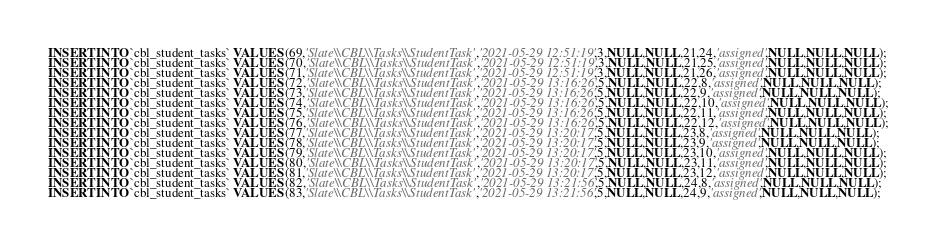<code> <loc_0><loc_0><loc_500><loc_500><_SQL_>INSERT INTO `cbl_student_tasks` VALUES (69,'Slate\\CBL\\Tasks\\StudentTask','2021-05-29 12:51:19',3,NULL,NULL,21,24,'assigned',NULL,NULL,NULL);
INSERT INTO `cbl_student_tasks` VALUES (70,'Slate\\CBL\\Tasks\\StudentTask','2021-05-29 12:51:19',3,NULL,NULL,21,25,'assigned',NULL,NULL,NULL);
INSERT INTO `cbl_student_tasks` VALUES (71,'Slate\\CBL\\Tasks\\StudentTask','2021-05-29 12:51:19',3,NULL,NULL,21,26,'assigned',NULL,NULL,NULL);
INSERT INTO `cbl_student_tasks` VALUES (72,'Slate\\CBL\\Tasks\\StudentTask','2021-05-29 13:16:26',5,NULL,NULL,22,8,'assigned',NULL,NULL,NULL);
INSERT INTO `cbl_student_tasks` VALUES (73,'Slate\\CBL\\Tasks\\StudentTask','2021-05-29 13:16:26',5,NULL,NULL,22,9,'assigned',NULL,NULL,NULL);
INSERT INTO `cbl_student_tasks` VALUES (74,'Slate\\CBL\\Tasks\\StudentTask','2021-05-29 13:16:26',5,NULL,NULL,22,10,'assigned',NULL,NULL,NULL);
INSERT INTO `cbl_student_tasks` VALUES (75,'Slate\\CBL\\Tasks\\StudentTask','2021-05-29 13:16:26',5,NULL,NULL,22,11,'assigned',NULL,NULL,NULL);
INSERT INTO `cbl_student_tasks` VALUES (76,'Slate\\CBL\\Tasks\\StudentTask','2021-05-29 13:16:26',5,NULL,NULL,22,12,'assigned',NULL,NULL,NULL);
INSERT INTO `cbl_student_tasks` VALUES (77,'Slate\\CBL\\Tasks\\StudentTask','2021-05-29 13:20:17',5,NULL,NULL,23,8,'assigned',NULL,NULL,NULL);
INSERT INTO `cbl_student_tasks` VALUES (78,'Slate\\CBL\\Tasks\\StudentTask','2021-05-29 13:20:17',5,NULL,NULL,23,9,'assigned',NULL,NULL,NULL);
INSERT INTO `cbl_student_tasks` VALUES (79,'Slate\\CBL\\Tasks\\StudentTask','2021-05-29 13:20:17',5,NULL,NULL,23,10,'assigned',NULL,NULL,NULL);
INSERT INTO `cbl_student_tasks` VALUES (80,'Slate\\CBL\\Tasks\\StudentTask','2021-05-29 13:20:17',5,NULL,NULL,23,11,'assigned',NULL,NULL,NULL);
INSERT INTO `cbl_student_tasks` VALUES (81,'Slate\\CBL\\Tasks\\StudentTask','2021-05-29 13:20:17',5,NULL,NULL,23,12,'assigned',NULL,NULL,NULL);
INSERT INTO `cbl_student_tasks` VALUES (82,'Slate\\CBL\\Tasks\\StudentTask','2021-05-29 13:21:56',5,NULL,NULL,24,8,'assigned',NULL,NULL,NULL);
INSERT INTO `cbl_student_tasks` VALUES (83,'Slate\\CBL\\Tasks\\StudentTask','2021-05-29 13:21:56',5,NULL,NULL,24,9,'assigned',NULL,NULL,NULL);</code> 